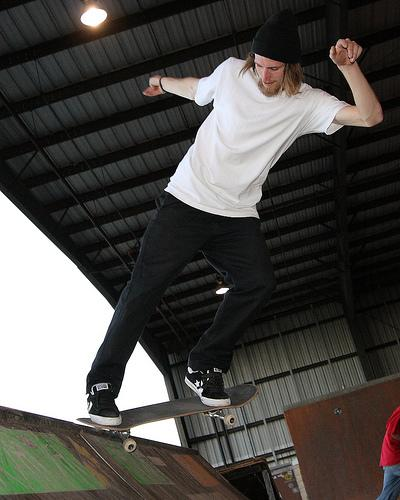Based on the information given, can you explain the type of trick the skateboarder might be attempting? The skateboarder appears to be attempting a banking trick off the side of the wooden sloped ramp. What is the primary action being performed by a person in the image? A skateboarder is skating on a ramp. What kind of object is the skateboarder interacting with during the skateboarding? The skateboarder is interacting with a wooden sloped ramp. Can you provide a brief description of the skateboarder's appearance in terms of clothing and physical features? The skateboarder has a beard, long hair, wears a black hat, dressed in black and white, and has a tee shirt, black trousers, and a hat. Assess the quality of the image by mentioning any issues or defects. The quality of the image appears to be fine as no defects or issues are mentioned in the description. Describe an interaction going on in the image that involves two objects. The skateboarder, wearing black and white shoes, is skating on a black skateboard with white wheels while performing a trick on a ramp. In the image, is there any apparent risk involved in the skateboarder's trick? Yes, there is an inherent risk in skateboarding, especially when attempting tricks on ramps. Proper safety equipment should be used to minimize injuries. Count the number of objects mentioned in the image. There are eight different objects mentioned in the image (including the skateboarder). Please identify any accessories or equipment present in the image. Wooden sloped ramp, right and left black and white shoes, skateboard wheel, metal axle under skateboard, black skateboard with white wheels. Analyze the sentiment of the image by describing its mood or vibe. The image has an energetic and exciting vibe as the skateboarder is performing a trick on a ramp. Are there any dogs playing on the ramp? No, it's not mentioned in the image. Is there a red sloped ramp for skating in the image? The ramp is described as wooden, not red. This question might make the viewer look for a red ramp that is not present. Can you find a skateboard with blue wheels in the image? The skateboard is described as having white wheels, not blue. This question might mislead the viewer to search for a skateboard with blue wheels, which doesn't be exist. Does the image feature a pair of green and purple shoes? The existent shoes are described as black and white, not green and purple. This question might trick the viewers to look for an incorrect pair of shoes. 